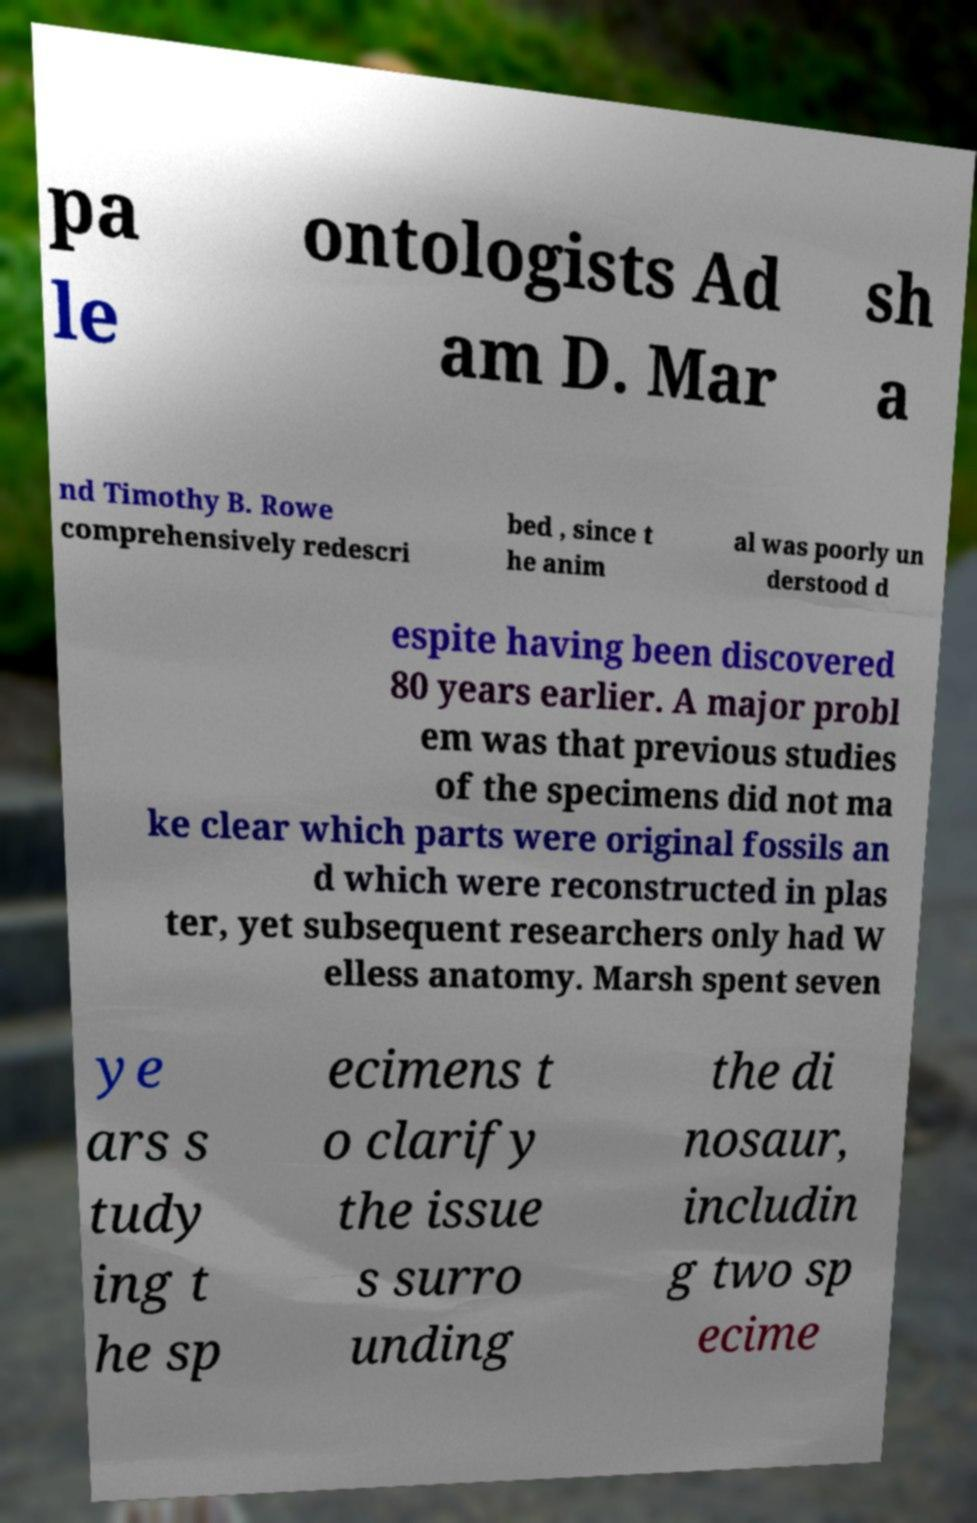Could you assist in decoding the text presented in this image and type it out clearly? pa le ontologists Ad am D. Mar sh a nd Timothy B. Rowe comprehensively redescri bed , since t he anim al was poorly un derstood d espite having been discovered 80 years earlier. A major probl em was that previous studies of the specimens did not ma ke clear which parts were original fossils an d which were reconstructed in plas ter, yet subsequent researchers only had W elless anatomy. Marsh spent seven ye ars s tudy ing t he sp ecimens t o clarify the issue s surro unding the di nosaur, includin g two sp ecime 